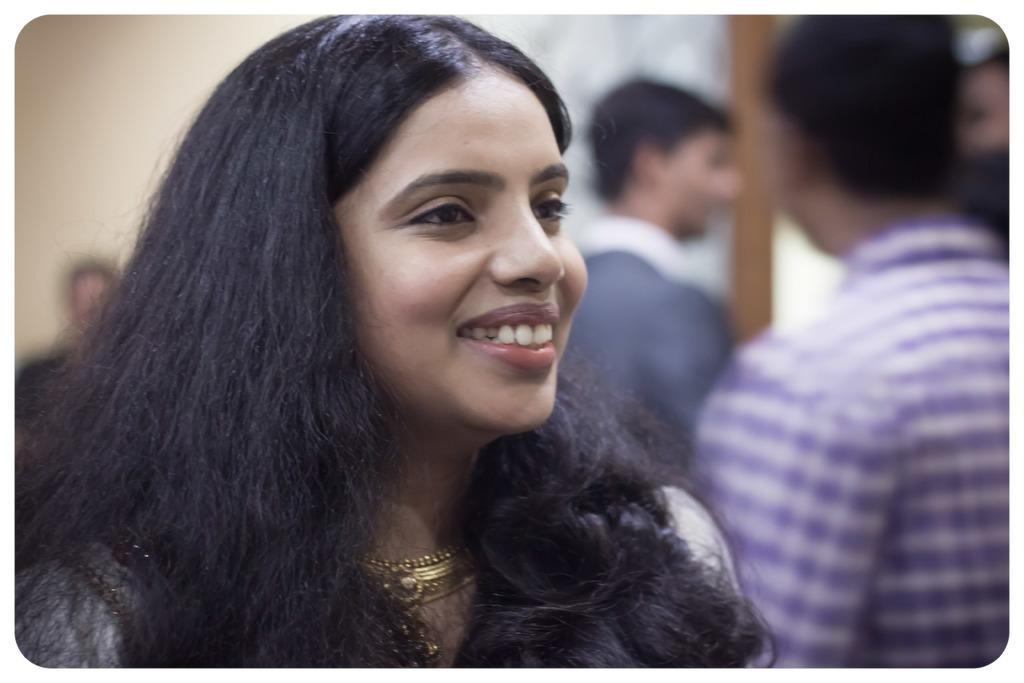How many people are in the image? There are people in the image, but the exact number is not specified. Can you describe the facial expression of one of the people? One person is smiling in the image. What can be said about the background of the image? The background of the image is blurred. What type of nail is being used by the person in the image? There is no nail visible in the image. How much sugar is being consumed by the person in the image? There is no indication of sugar consumption in the image. 